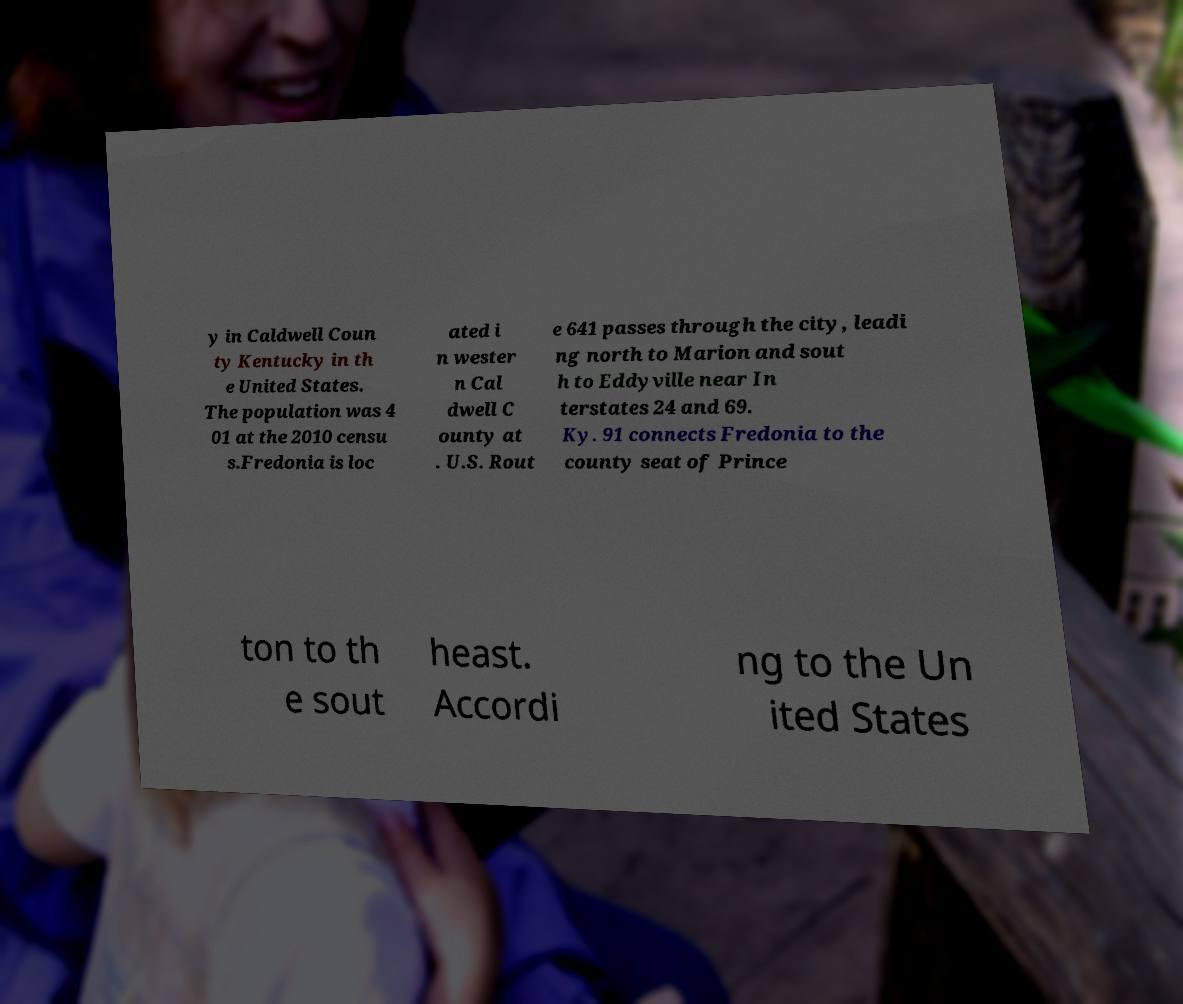Could you extract and type out the text from this image? y in Caldwell Coun ty Kentucky in th e United States. The population was 4 01 at the 2010 censu s.Fredonia is loc ated i n wester n Cal dwell C ounty at . U.S. Rout e 641 passes through the city, leadi ng north to Marion and sout h to Eddyville near In terstates 24 and 69. Ky. 91 connects Fredonia to the county seat of Prince ton to th e sout heast. Accordi ng to the Un ited States 